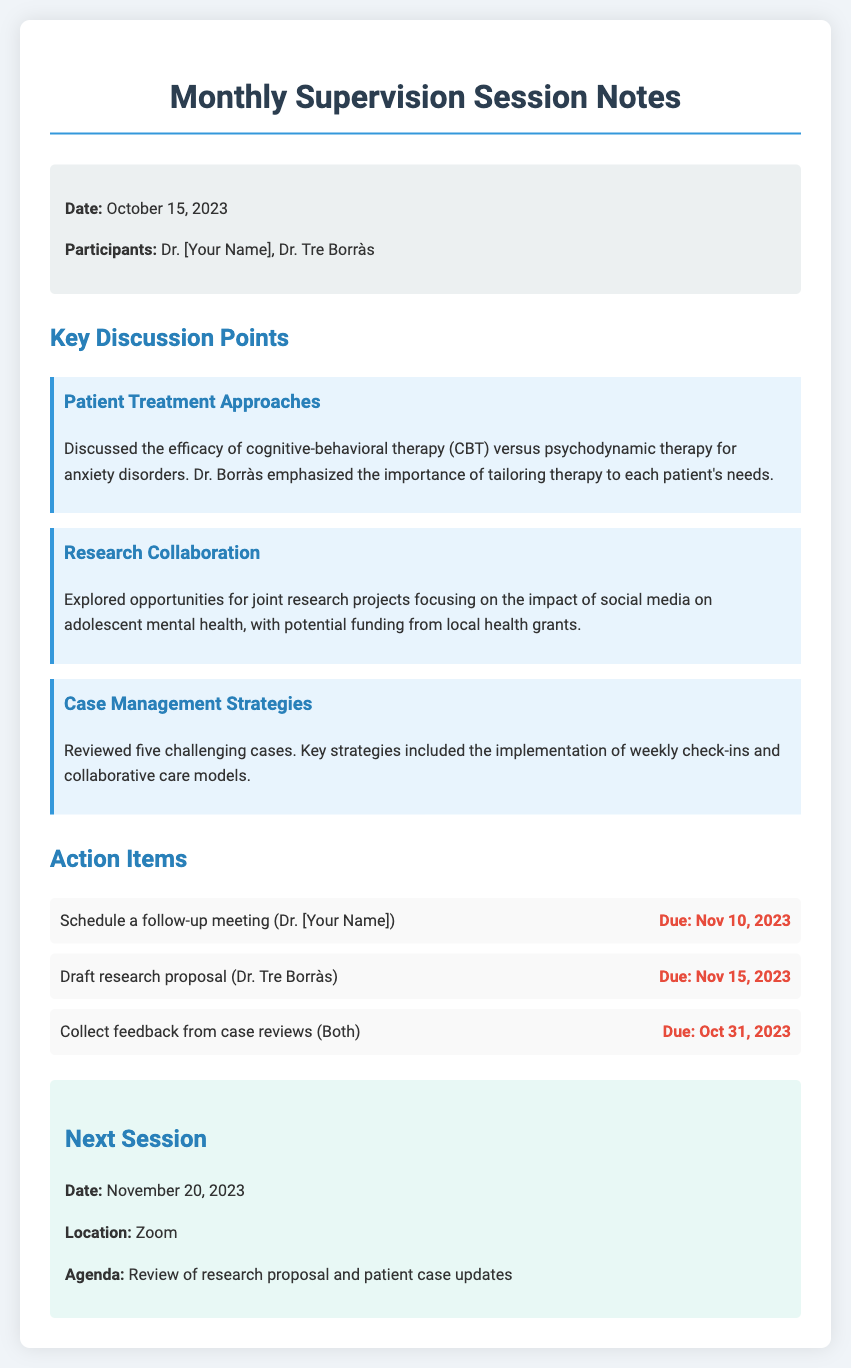What was the date of the session? The date of the session is explicitly mentioned in the document under the session info section.
Answer: October 15, 2023 Who are the participants in the session? The participants are listed in the session info section, specifying who attended the meeting.
Answer: Dr. [Your Name], Dr. Tre Borràs What is one key topic discussed regarding therapy? One of the key discussion points includes a comparison between two therapy approaches for anxiety disorders.
Answer: Cognitive-behavioral therapy versus psychodynamic therapy What is the due date for collecting feedback from case reviews? The due date for this action item is specified in the action items section.
Answer: October 31, 2023 Where will the next session take place? The location for the next session is outlined in the next session section.
Answer: Zoom How many challenging cases were reviewed? The document states the number of cases reviewed during the meeting as a part of the case management strategies.
Answer: Five What is the agenda for the next session? The agenda for the following session is outlined in the next session section.
Answer: Review of research proposal and patient case updates Who is responsible for drafting the research proposal? The document clearly assigns this action item to one of the participants.
Answer: Dr. Tre Borràs What is the next session date? The date for the next meeting is explicitly listed in the document.
Answer: November 20, 2023 